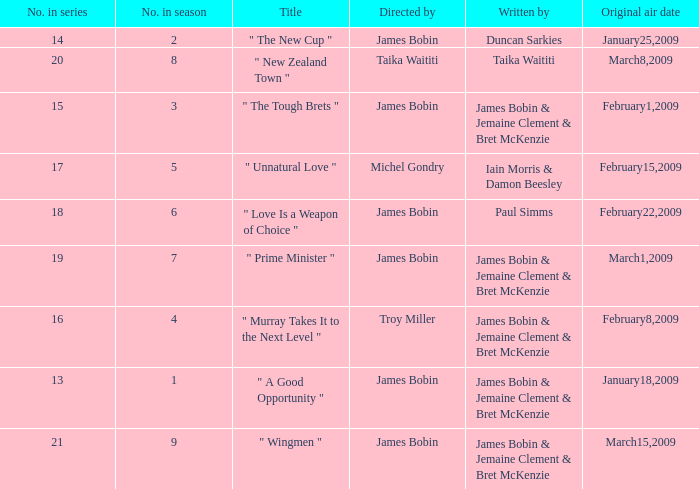 what's the title where original air date is january18,2009 " A Good Opportunity ". 